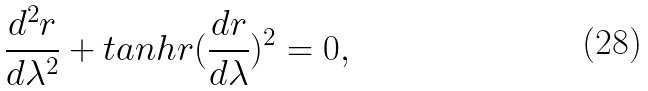Convert formula to latex. <formula><loc_0><loc_0><loc_500><loc_500>\frac { d ^ { 2 } r } { d \lambda ^ { 2 } } + t a n h r ( \frac { d r } { d \lambda } ) ^ { 2 } = 0 ,</formula> 